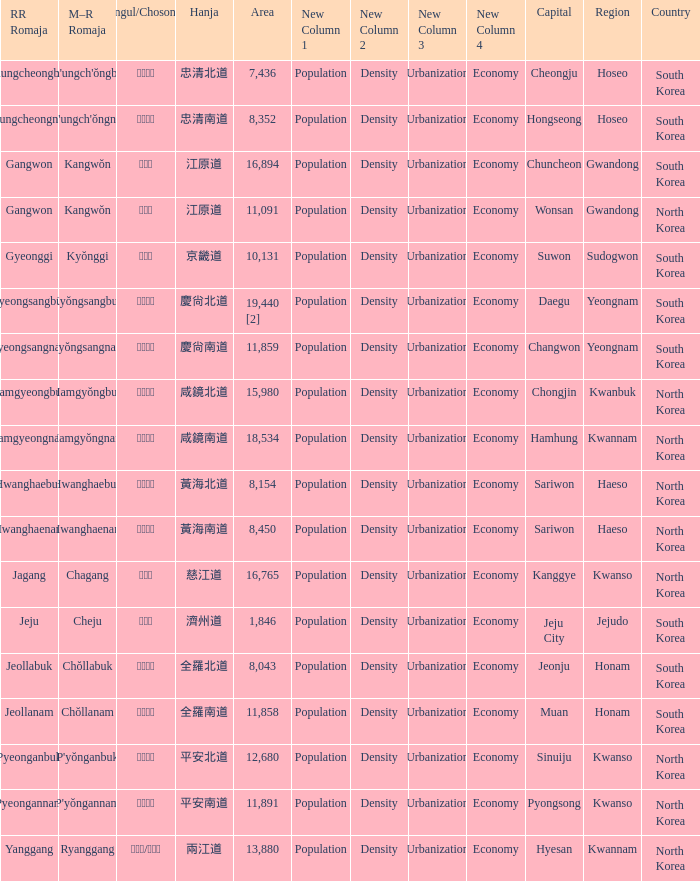Could you parse the entire table? {'header': ['RR Romaja', 'M–R Romaja', 'Hangul/Chosongul', 'Hanja', 'Area', 'New Column 1', 'New Column 2', 'New Column 3', 'New Column 4', 'Capital', 'Region', 'Country'], 'rows': [['Chungcheongbuk', "Ch'ungch'ŏngbuk", '충청북도', '忠清北道', '7,436', 'Population', 'Density', 'Urbanization', 'Economy', 'Cheongju', 'Hoseo', 'South Korea'], ['Chungcheongnam', "Ch'ungch'ŏngnam", '충청남도', '忠清南道', '8,352', 'Population', 'Density', 'Urbanization', 'Economy', 'Hongseong', 'Hoseo', 'South Korea'], ['Gangwon', 'Kangwŏn', '강원도', '江原道', '16,894', 'Population', 'Density', 'Urbanization', 'Economy', 'Chuncheon', 'Gwandong', 'South Korea'], ['Gangwon', 'Kangwŏn', '강원도', '江原道', '11,091', 'Population', 'Density', 'Urbanization', 'Economy', 'Wonsan', 'Gwandong', 'North Korea'], ['Gyeonggi', 'Kyŏnggi', '경기도', '京畿道', '10,131', 'Population', 'Density', 'Urbanization', 'Economy', 'Suwon', 'Sudogwon', 'South Korea'], ['Gyeongsangbuk', 'Kyŏngsangbuk', '경상북도', '慶尙北道', '19,440 [2]', 'Population', 'Density', 'Urbanization', 'Economy', 'Daegu', 'Yeongnam', 'South Korea'], ['Gyeongsangnam', 'Kyŏngsangnam', '경상남도', '慶尙南道', '11,859', 'Population', 'Density', 'Urbanization', 'Economy', 'Changwon', 'Yeongnam', 'South Korea'], ['Hamgyeongbuk', 'Hamgyŏngbuk', '함경북도', '咸鏡北道', '15,980', 'Population', 'Density', 'Urbanization', 'Economy', 'Chongjin', 'Kwanbuk', 'North Korea'], ['Hamgyeongnam', 'Hamgyŏngnam', '함경남도', '咸鏡南道', '18,534', 'Population', 'Density', 'Urbanization', 'Economy', 'Hamhung', 'Kwannam', 'North Korea'], ['Hwanghaebuk', 'Hwanghaebuk', '황해북도', '黃海北道', '8,154', 'Population', 'Density', 'Urbanization', 'Economy', 'Sariwon', 'Haeso', 'North Korea'], ['Hwanghaenam', 'Hwanghaenam', '황해남도', '黃海南道', '8,450', 'Population', 'Density', 'Urbanization', 'Economy', 'Sariwon', 'Haeso', 'North Korea'], ['Jagang', 'Chagang', '자강도', '慈江道', '16,765', 'Population', 'Density', 'Urbanization', 'Economy', 'Kanggye', 'Kwanso', 'North Korea'], ['Jeju', 'Cheju', '제주도', '濟州道', '1,846', 'Population', 'Density', 'Urbanization', 'Economy', 'Jeju City', 'Jejudo', 'South Korea'], ['Jeollabuk', 'Chŏllabuk', '전라북도', '全羅北道', '8,043', 'Population', 'Density', 'Urbanization', 'Economy', 'Jeonju', 'Honam', 'South Korea'], ['Jeollanam', 'Chŏllanam', '전라남도', '全羅南道', '11,858', 'Population', 'Density', 'Urbanization', 'Economy', 'Muan', 'Honam', 'South Korea'], ['Pyeonganbuk', "P'yŏnganbuk", '평안북도', '平安北道', '12,680', 'Population', 'Density', 'Urbanization', 'Economy', 'Sinuiju', 'Kwanso', 'North Korea'], ['Pyeongannam', "P'yŏngannam", '평안남도', '平安南道', '11,891', 'Population', 'Density', 'Urbanization', 'Economy', 'Pyongsong', 'Kwanso', 'North Korea'], ['Yanggang', 'Ryanggang', '량강도/양강도', '兩江道', '13,880', 'Population', 'Density', 'Urbanization', 'Economy', 'Hyesan', 'Kwannam', 'North Korea']]} What is the area for the province having Hangul of 경기도? 10131.0. 